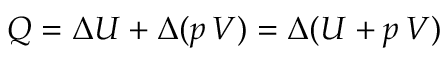<formula> <loc_0><loc_0><loc_500><loc_500>Q = \Delta U + \Delta ( p \, V ) = \Delta ( U + p \, V )</formula> 